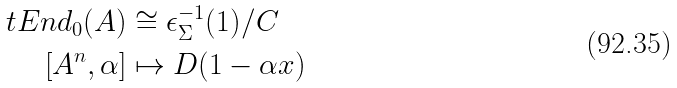<formula> <loc_0><loc_0><loc_500><loc_500>\ t E n d _ { 0 } ( A ) & \cong \epsilon _ { \Sigma } ^ { - 1 } ( 1 ) / C \\ [ A ^ { n } , \alpha ] & \mapsto D ( 1 - \alpha x )</formula> 